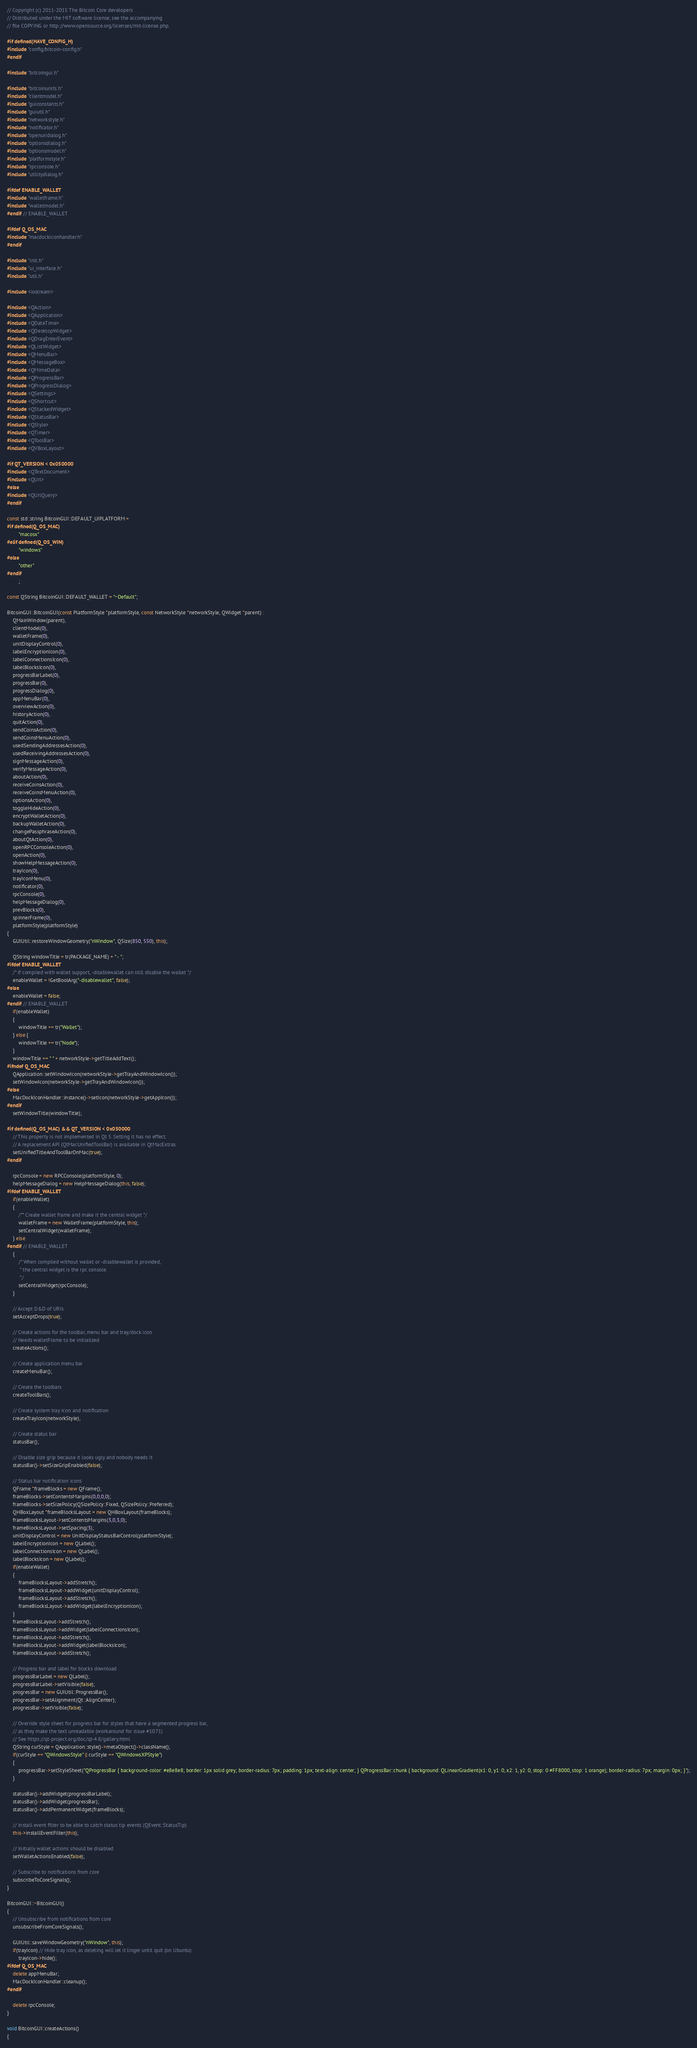Convert code to text. <code><loc_0><loc_0><loc_500><loc_500><_C++_>// Copyright (c) 2011-2015 The Bitcoin Core developers
// Distributed under the MIT software license, see the accompanying
// file COPYING or http://www.opensource.org/licenses/mit-license.php.

#if defined(HAVE_CONFIG_H)
#include "config/bitcoin-config.h"
#endif

#include "bitcoingui.h"

#include "bitcoinunits.h"
#include "clientmodel.h"
#include "guiconstants.h"
#include "guiutil.h"
#include "networkstyle.h"
#include "notificator.h"
#include "openuridialog.h"
#include "optionsdialog.h"
#include "optionsmodel.h"
#include "platformstyle.h"
#include "rpcconsole.h"
#include "utilitydialog.h"

#ifdef ENABLE_WALLET
#include "walletframe.h"
#include "walletmodel.h"
#endif // ENABLE_WALLET

#ifdef Q_OS_MAC
#include "macdockiconhandler.h"
#endif

#include "init.h"
#include "ui_interface.h"
#include "util.h"

#include <iostream>

#include <QAction>
#include <QApplication>
#include <QDateTime>
#include <QDesktopWidget>
#include <QDragEnterEvent>
#include <QListWidget>
#include <QMenuBar>
#include <QMessageBox>
#include <QMimeData>
#include <QProgressBar>
#include <QProgressDialog>
#include <QSettings>
#include <QShortcut>
#include <QStackedWidget>
#include <QStatusBar>
#include <QStyle>
#include <QTimer>
#include <QToolBar>
#include <QVBoxLayout>

#if QT_VERSION < 0x050000
#include <QTextDocument>
#include <QUrl>
#else
#include <QUrlQuery>
#endif

const std::string BitcoinGUI::DEFAULT_UIPLATFORM =
#if defined(Q_OS_MAC)
        "macosx"
#elif defined(Q_OS_WIN)
        "windows"
#else
        "other"
#endif
        ;

const QString BitcoinGUI::DEFAULT_WALLET = "~Default";

BitcoinGUI::BitcoinGUI(const PlatformStyle *platformStyle, const NetworkStyle *networkStyle, QWidget *parent) :
    QMainWindow(parent),
    clientModel(0),
    walletFrame(0),
    unitDisplayControl(0),
    labelEncryptionIcon(0),
    labelConnectionsIcon(0),
    labelBlocksIcon(0),
    progressBarLabel(0),
    progressBar(0),
    progressDialog(0),
    appMenuBar(0),
    overviewAction(0),
    historyAction(0),
    quitAction(0),
    sendCoinsAction(0),
    sendCoinsMenuAction(0),
    usedSendingAddressesAction(0),
    usedReceivingAddressesAction(0),
    signMessageAction(0),
    verifyMessageAction(0),
    aboutAction(0),
    receiveCoinsAction(0),
    receiveCoinsMenuAction(0),
    optionsAction(0),
    toggleHideAction(0),
    encryptWalletAction(0),
    backupWalletAction(0),
    changePassphraseAction(0),
    aboutQtAction(0),
    openRPCConsoleAction(0),
    openAction(0),
    showHelpMessageAction(0),
    trayIcon(0),
    trayIconMenu(0),
    notificator(0),
    rpcConsole(0),
    helpMessageDialog(0),
    prevBlocks(0),
    spinnerFrame(0),
    platformStyle(platformStyle)
{
    GUIUtil::restoreWindowGeometry("nWindow", QSize(850, 550), this);

    QString windowTitle = tr(PACKAGE_NAME) + " - ";
#ifdef ENABLE_WALLET
    /* if compiled with wallet support, -disablewallet can still disable the wallet */
    enableWallet = !GetBoolArg("-disablewallet", false);
#else
    enableWallet = false;
#endif // ENABLE_WALLET
    if(enableWallet)
    {
        windowTitle += tr("Wallet");
    } else {
        windowTitle += tr("Node");
    }
    windowTitle += " " + networkStyle->getTitleAddText();
#ifndef Q_OS_MAC
    QApplication::setWindowIcon(networkStyle->getTrayAndWindowIcon());
    setWindowIcon(networkStyle->getTrayAndWindowIcon());
#else
    MacDockIconHandler::instance()->setIcon(networkStyle->getAppIcon());
#endif
    setWindowTitle(windowTitle);

#if defined(Q_OS_MAC) && QT_VERSION < 0x050000
    // This property is not implemented in Qt 5. Setting it has no effect.
    // A replacement API (QtMacUnifiedToolBar) is available in QtMacExtras.
    setUnifiedTitleAndToolBarOnMac(true);
#endif

    rpcConsole = new RPCConsole(platformStyle, 0);
    helpMessageDialog = new HelpMessageDialog(this, false);
#ifdef ENABLE_WALLET
    if(enableWallet)
    {
        /** Create wallet frame and make it the central widget */
        walletFrame = new WalletFrame(platformStyle, this);
        setCentralWidget(walletFrame);
    } else
#endif // ENABLE_WALLET
    {
        /* When compiled without wallet or -disablewallet is provided,
         * the central widget is the rpc console.
         */
        setCentralWidget(rpcConsole);
    }

    // Accept D&D of URIs
    setAcceptDrops(true);

    // Create actions for the toolbar, menu bar and tray/dock icon
    // Needs walletFrame to be initialized
    createActions();

    // Create application menu bar
    createMenuBar();

    // Create the toolbars
    createToolBars();

    // Create system tray icon and notification
    createTrayIcon(networkStyle);

    // Create status bar
    statusBar();

    // Disable size grip because it looks ugly and nobody needs it
    statusBar()->setSizeGripEnabled(false);

    // Status bar notification icons
    QFrame *frameBlocks = new QFrame();
    frameBlocks->setContentsMargins(0,0,0,0);
    frameBlocks->setSizePolicy(QSizePolicy::Fixed, QSizePolicy::Preferred);
    QHBoxLayout *frameBlocksLayout = new QHBoxLayout(frameBlocks);
    frameBlocksLayout->setContentsMargins(3,0,3,0);
    frameBlocksLayout->setSpacing(3);
    unitDisplayControl = new UnitDisplayStatusBarControl(platformStyle);
    labelEncryptionIcon = new QLabel();
    labelConnectionsIcon = new QLabel();
    labelBlocksIcon = new QLabel();
    if(enableWallet)
    {
        frameBlocksLayout->addStretch();
        frameBlocksLayout->addWidget(unitDisplayControl);
        frameBlocksLayout->addStretch();
        frameBlocksLayout->addWidget(labelEncryptionIcon);
    }
    frameBlocksLayout->addStretch();
    frameBlocksLayout->addWidget(labelConnectionsIcon);
    frameBlocksLayout->addStretch();
    frameBlocksLayout->addWidget(labelBlocksIcon);
    frameBlocksLayout->addStretch();

    // Progress bar and label for blocks download
    progressBarLabel = new QLabel();
    progressBarLabel->setVisible(false);
    progressBar = new GUIUtil::ProgressBar();
    progressBar->setAlignment(Qt::AlignCenter);
    progressBar->setVisible(false);

    // Override style sheet for progress bar for styles that have a segmented progress bar,
    // as they make the text unreadable (workaround for issue #1071)
    // See https://qt-project.org/doc/qt-4.8/gallery.html
    QString curStyle = QApplication::style()->metaObject()->className();
    if(curStyle == "QWindowsStyle" || curStyle == "QWindowsXPStyle")
    {
        progressBar->setStyleSheet("QProgressBar { background-color: #e8e8e8; border: 1px solid grey; border-radius: 7px; padding: 1px; text-align: center; } QProgressBar::chunk { background: QLinearGradient(x1: 0, y1: 0, x2: 1, y2: 0, stop: 0 #FF8000, stop: 1 orange); border-radius: 7px; margin: 0px; }");
    }

    statusBar()->addWidget(progressBarLabel);
    statusBar()->addWidget(progressBar);
    statusBar()->addPermanentWidget(frameBlocks);

    // Install event filter to be able to catch status tip events (QEvent::StatusTip)
    this->installEventFilter(this);

    // Initially wallet actions should be disabled
    setWalletActionsEnabled(false);

    // Subscribe to notifications from core
    subscribeToCoreSignals();
}

BitcoinGUI::~BitcoinGUI()
{
    // Unsubscribe from notifications from core
    unsubscribeFromCoreSignals();

    GUIUtil::saveWindowGeometry("nWindow", this);
    if(trayIcon) // Hide tray icon, as deleting will let it linger until quit (on Ubuntu)
        trayIcon->hide();
#ifdef Q_OS_MAC
    delete appMenuBar;
    MacDockIconHandler::cleanup();
#endif

    delete rpcConsole;
}

void BitcoinGUI::createActions()
{</code> 